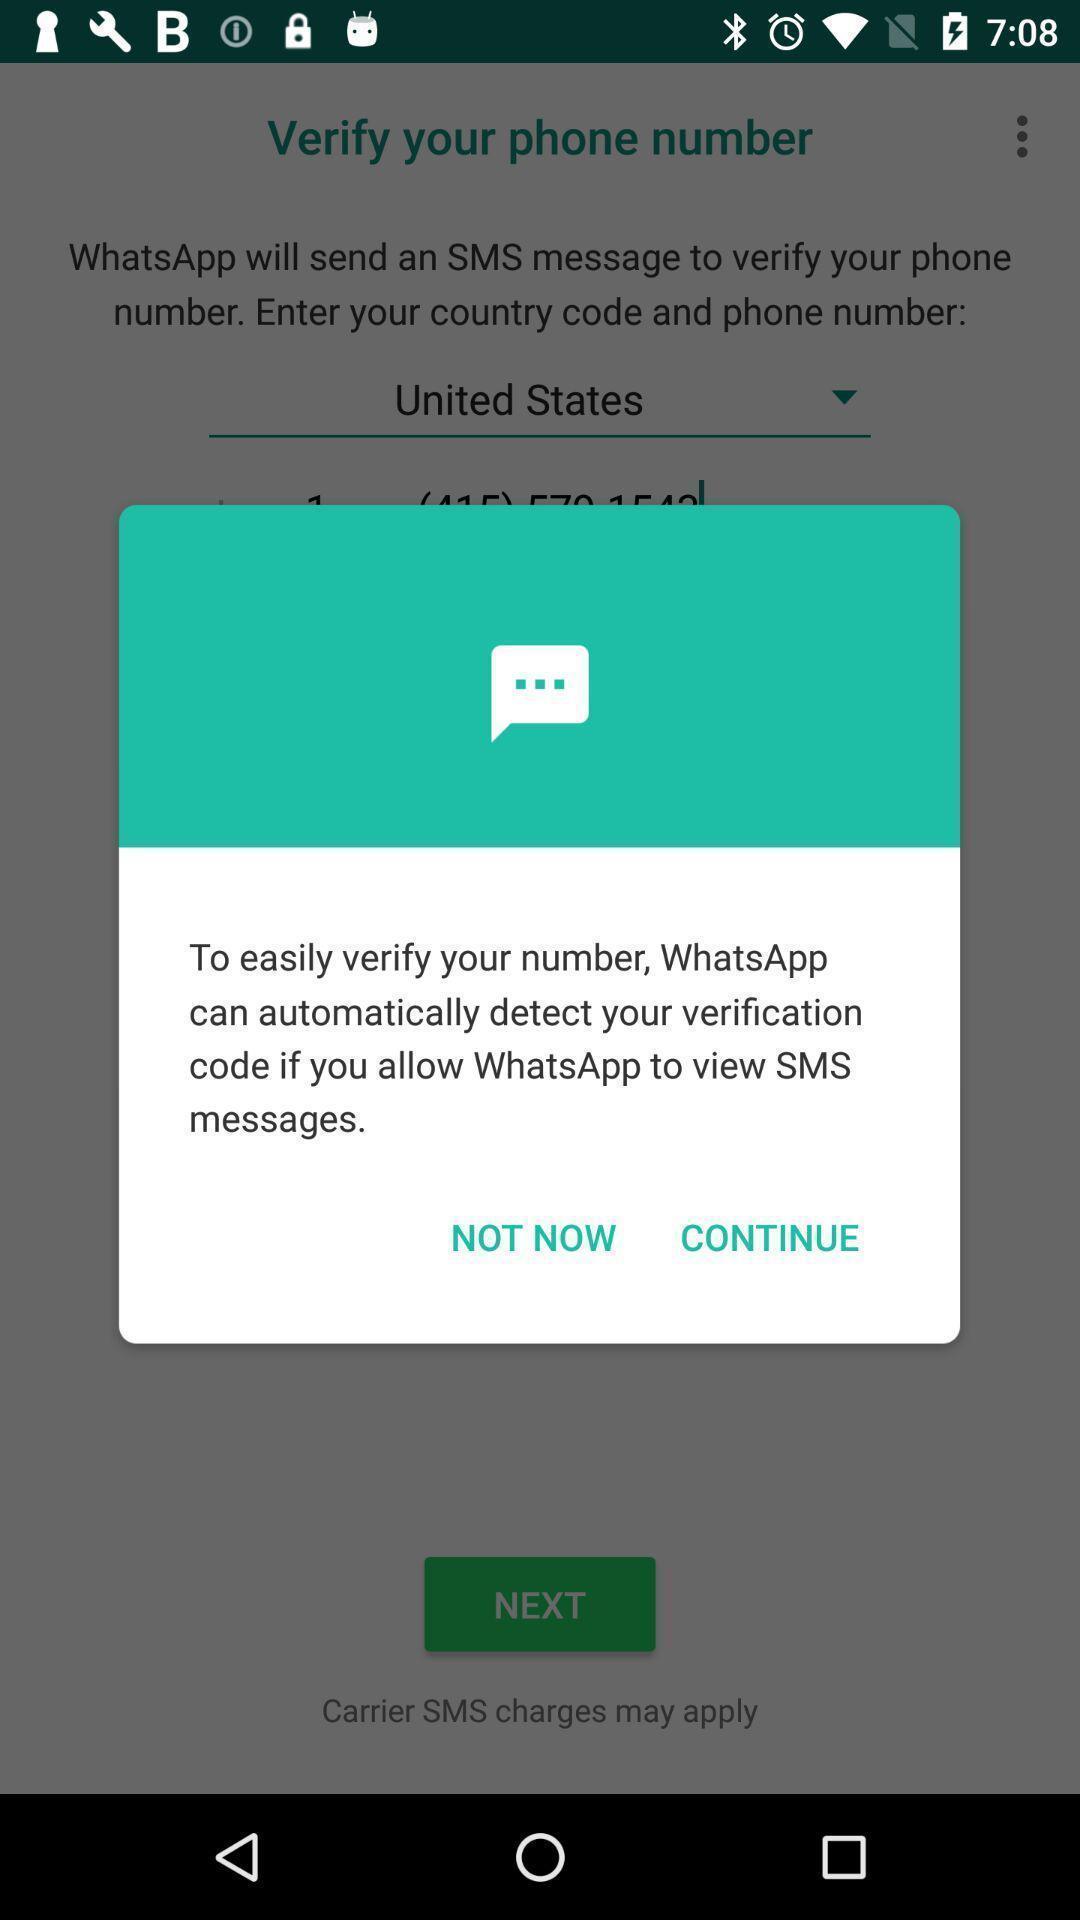Describe the visual elements of this screenshot. Verification pop up of a messaging app. 